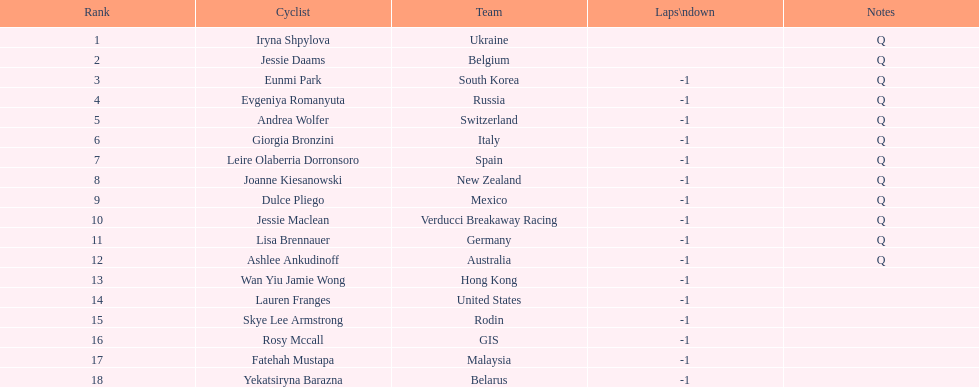In this race, who was the competitor with the best ranking? Iryna Shpylova. 